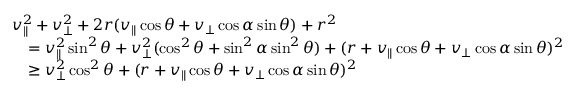Convert formula to latex. <formula><loc_0><loc_0><loc_500><loc_500>\begin{array} { r l } & { v _ { \| } ^ { 2 } + v _ { \perp } ^ { 2 } + 2 r ( v _ { \| } \cos \theta + v _ { \perp } \cos \alpha \sin \theta ) + r ^ { 2 } } \\ & { \quad = v _ { \| } ^ { 2 } \sin ^ { 2 } \theta + v _ { \perp } ^ { 2 } ( \cos ^ { 2 } \theta + \sin ^ { 2 } \alpha \sin ^ { 2 } \theta ) + ( r + v _ { \| } \cos \theta + v _ { \perp } \cos \alpha \sin \theta ) ^ { 2 } } \\ & { \quad \geq v _ { \perp } ^ { 2 } \cos ^ { 2 } \theta + ( r + v _ { \| } \cos \theta + v _ { \perp } \cos \alpha \sin \theta ) ^ { 2 } } \end{array}</formula> 